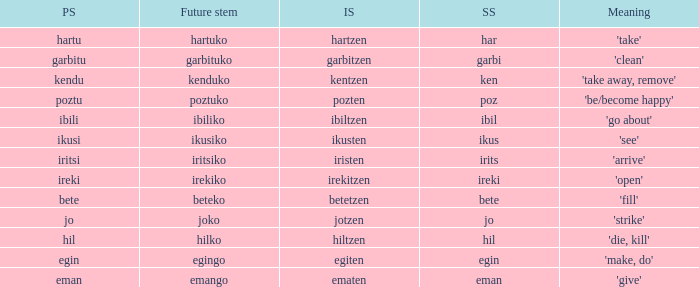Name the perfect stem for jo 1.0. 